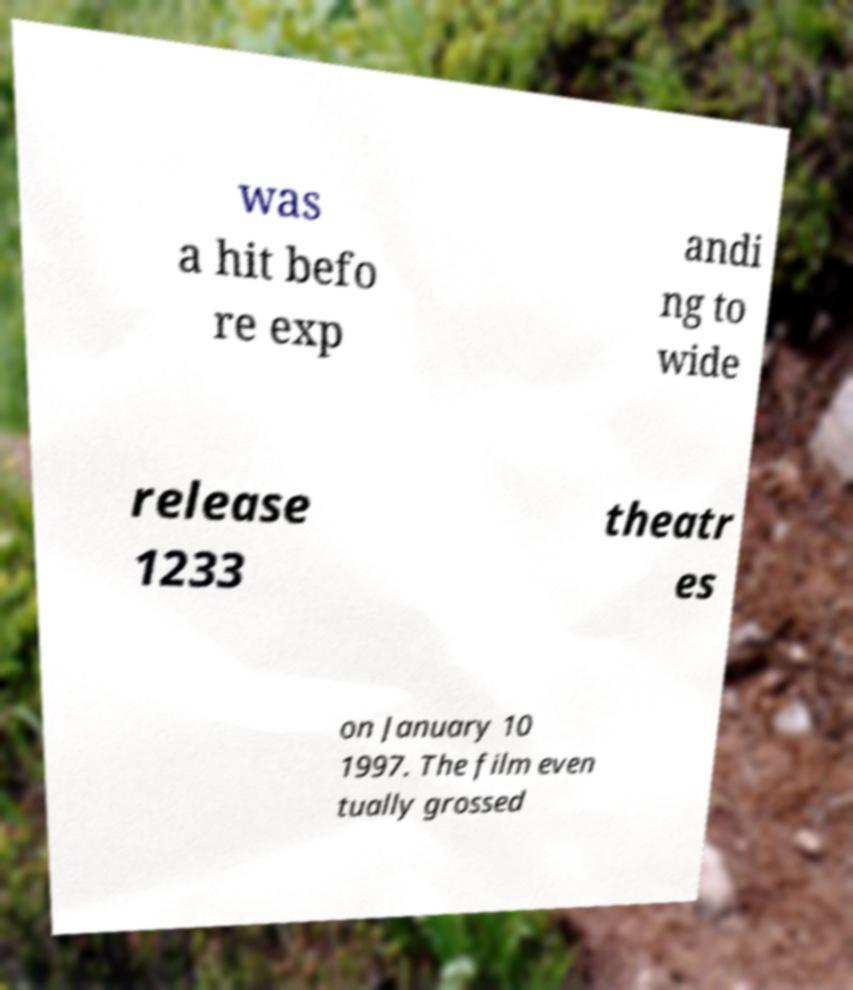Can you read and provide the text displayed in the image?This photo seems to have some interesting text. Can you extract and type it out for me? was a hit befo re exp andi ng to wide release 1233 theatr es on January 10 1997. The film even tually grossed 